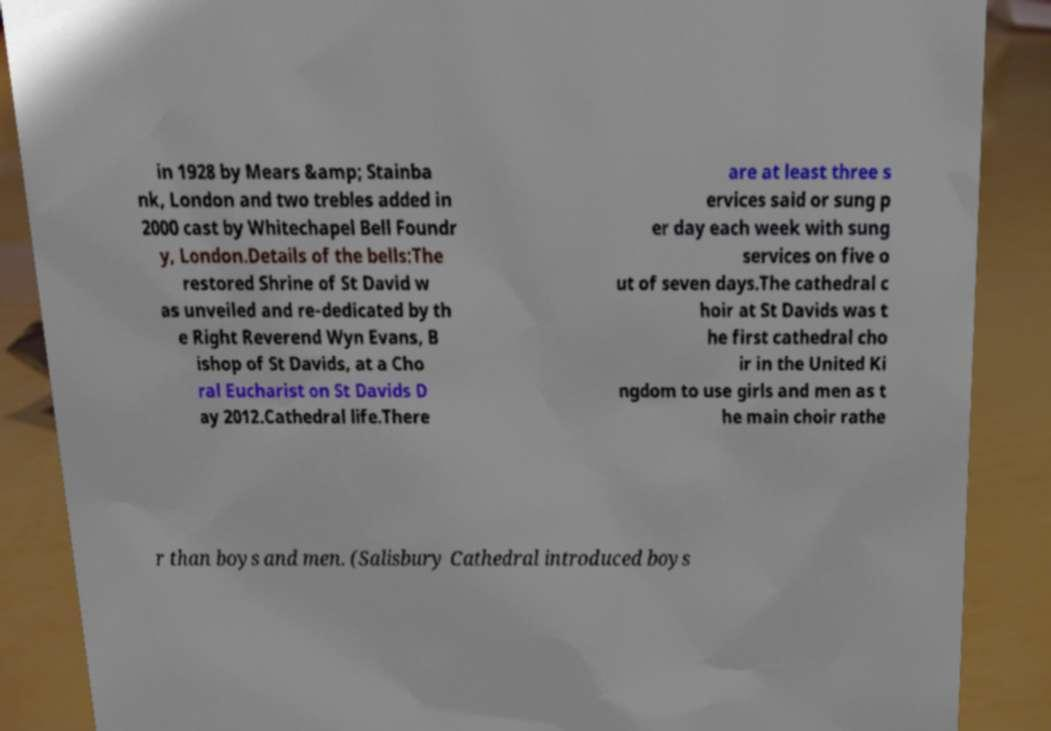For documentation purposes, I need the text within this image transcribed. Could you provide that? in 1928 by Mears &amp; Stainba nk, London and two trebles added in 2000 cast by Whitechapel Bell Foundr y, London.Details of the bells:The restored Shrine of St David w as unveiled and re-dedicated by th e Right Reverend Wyn Evans, B ishop of St Davids, at a Cho ral Eucharist on St Davids D ay 2012.Cathedral life.There are at least three s ervices said or sung p er day each week with sung services on five o ut of seven days.The cathedral c hoir at St Davids was t he first cathedral cho ir in the United Ki ngdom to use girls and men as t he main choir rathe r than boys and men. (Salisbury Cathedral introduced boys 